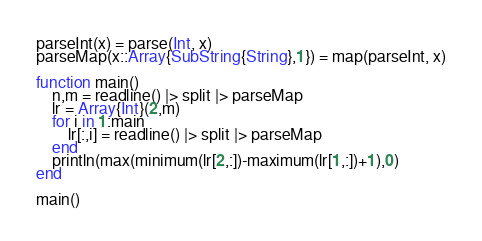<code> <loc_0><loc_0><loc_500><loc_500><_Julia_>parseInt(x) = parse(Int, x)
parseMap(x::Array{SubString{String},1}) = map(parseInt, x)

function main()
	n,m = readline() |> split |> parseMap
	lr = Array{Int}(2,m)
	for i in 1:main
		lr[:,i] = readline() |> split |> parseMap
	end
	println(max(minimum(lr[2,:])-maximum(lr[1,:])+1),0)
end

main()</code> 